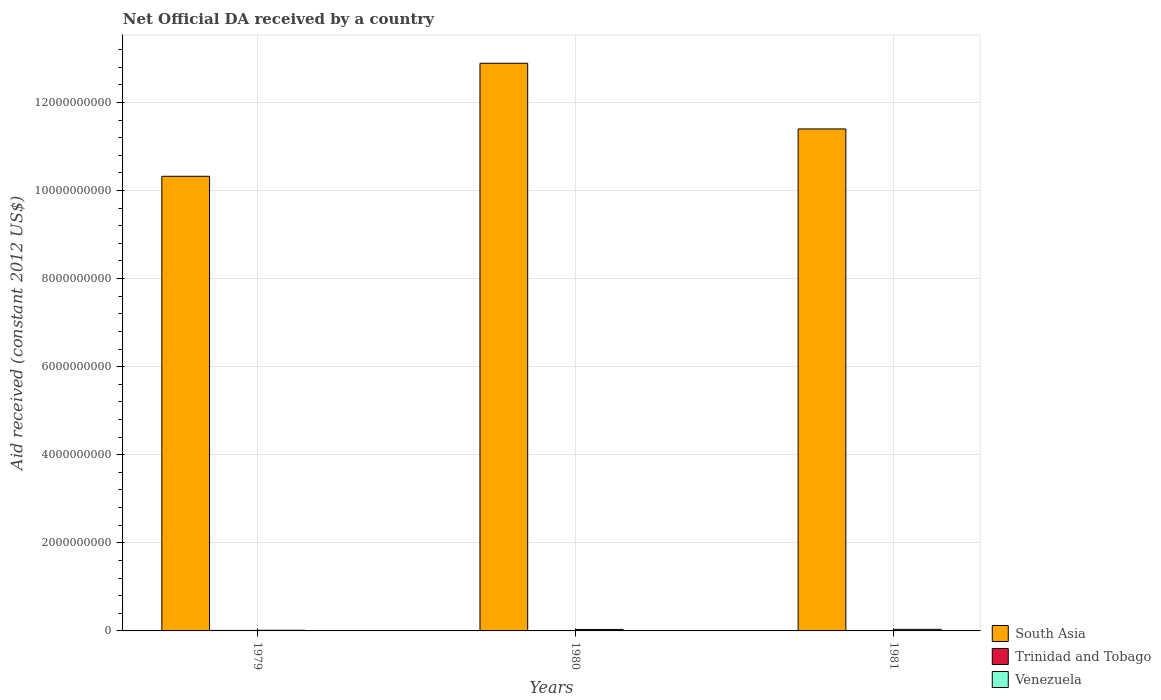Are the number of bars on each tick of the X-axis equal?
Ensure brevity in your answer.  No. How many bars are there on the 3rd tick from the left?
Ensure brevity in your answer.  2. What is the label of the 2nd group of bars from the left?
Make the answer very short. 1980. In how many cases, is the number of bars for a given year not equal to the number of legend labels?
Keep it short and to the point. 1. What is the net official development assistance aid received in Venezuela in 1979?
Keep it short and to the point. 1.50e+07. Across all years, what is the maximum net official development assistance aid received in South Asia?
Provide a succinct answer. 1.29e+1. Across all years, what is the minimum net official development assistance aid received in Venezuela?
Your response must be concise. 1.50e+07. What is the total net official development assistance aid received in Trinidad and Tobago in the graph?
Give a very brief answer. 2.02e+07. What is the difference between the net official development assistance aid received in Trinidad and Tobago in 1979 and that in 1980?
Keep it short and to the point. 1.99e+06. What is the difference between the net official development assistance aid received in South Asia in 1979 and the net official development assistance aid received in Venezuela in 1980?
Provide a short and direct response. 1.03e+1. What is the average net official development assistance aid received in Venezuela per year?
Provide a succinct answer. 2.82e+07. In the year 1980, what is the difference between the net official development assistance aid received in Trinidad and Tobago and net official development assistance aid received in South Asia?
Make the answer very short. -1.29e+1. What is the ratio of the net official development assistance aid received in Venezuela in 1979 to that in 1981?
Your answer should be very brief. 0.42. Is the net official development assistance aid received in South Asia in 1979 less than that in 1980?
Keep it short and to the point. Yes. What is the difference between the highest and the second highest net official development assistance aid received in Venezuela?
Offer a terse response. 2.73e+06. What is the difference between the highest and the lowest net official development assistance aid received in Trinidad and Tobago?
Your answer should be compact. 1.11e+07. In how many years, is the net official development assistance aid received in South Asia greater than the average net official development assistance aid received in South Asia taken over all years?
Provide a succinct answer. 1. Is it the case that in every year, the sum of the net official development assistance aid received in Trinidad and Tobago and net official development assistance aid received in Venezuela is greater than the net official development assistance aid received in South Asia?
Make the answer very short. No. How many bars are there?
Keep it short and to the point. 8. Are all the bars in the graph horizontal?
Ensure brevity in your answer.  No. How many years are there in the graph?
Your response must be concise. 3. What is the difference between two consecutive major ticks on the Y-axis?
Ensure brevity in your answer.  2.00e+09. Does the graph contain any zero values?
Offer a very short reply. Yes. Does the graph contain grids?
Offer a terse response. Yes. How many legend labels are there?
Keep it short and to the point. 3. How are the legend labels stacked?
Provide a short and direct response. Vertical. What is the title of the graph?
Ensure brevity in your answer.  Net Official DA received by a country. What is the label or title of the X-axis?
Offer a very short reply. Years. What is the label or title of the Y-axis?
Your response must be concise. Aid received (constant 2012 US$). What is the Aid received (constant 2012 US$) of South Asia in 1979?
Offer a very short reply. 1.03e+1. What is the Aid received (constant 2012 US$) of Trinidad and Tobago in 1979?
Your answer should be compact. 1.11e+07. What is the Aid received (constant 2012 US$) in Venezuela in 1979?
Keep it short and to the point. 1.50e+07. What is the Aid received (constant 2012 US$) of South Asia in 1980?
Make the answer very short. 1.29e+1. What is the Aid received (constant 2012 US$) in Trinidad and Tobago in 1980?
Give a very brief answer. 9.10e+06. What is the Aid received (constant 2012 US$) of Venezuela in 1980?
Ensure brevity in your answer.  3.34e+07. What is the Aid received (constant 2012 US$) in South Asia in 1981?
Keep it short and to the point. 1.14e+1. What is the Aid received (constant 2012 US$) of Venezuela in 1981?
Offer a very short reply. 3.61e+07. Across all years, what is the maximum Aid received (constant 2012 US$) of South Asia?
Provide a succinct answer. 1.29e+1. Across all years, what is the maximum Aid received (constant 2012 US$) of Trinidad and Tobago?
Provide a short and direct response. 1.11e+07. Across all years, what is the maximum Aid received (constant 2012 US$) in Venezuela?
Make the answer very short. 3.61e+07. Across all years, what is the minimum Aid received (constant 2012 US$) of South Asia?
Give a very brief answer. 1.03e+1. Across all years, what is the minimum Aid received (constant 2012 US$) of Venezuela?
Offer a very short reply. 1.50e+07. What is the total Aid received (constant 2012 US$) in South Asia in the graph?
Keep it short and to the point. 3.46e+1. What is the total Aid received (constant 2012 US$) in Trinidad and Tobago in the graph?
Offer a terse response. 2.02e+07. What is the total Aid received (constant 2012 US$) of Venezuela in the graph?
Your response must be concise. 8.45e+07. What is the difference between the Aid received (constant 2012 US$) of South Asia in 1979 and that in 1980?
Give a very brief answer. -2.57e+09. What is the difference between the Aid received (constant 2012 US$) in Trinidad and Tobago in 1979 and that in 1980?
Offer a very short reply. 1.99e+06. What is the difference between the Aid received (constant 2012 US$) in Venezuela in 1979 and that in 1980?
Provide a succinct answer. -1.84e+07. What is the difference between the Aid received (constant 2012 US$) of South Asia in 1979 and that in 1981?
Offer a very short reply. -1.08e+09. What is the difference between the Aid received (constant 2012 US$) in Venezuela in 1979 and that in 1981?
Ensure brevity in your answer.  -2.11e+07. What is the difference between the Aid received (constant 2012 US$) of South Asia in 1980 and that in 1981?
Give a very brief answer. 1.49e+09. What is the difference between the Aid received (constant 2012 US$) of Venezuela in 1980 and that in 1981?
Offer a very short reply. -2.73e+06. What is the difference between the Aid received (constant 2012 US$) of South Asia in 1979 and the Aid received (constant 2012 US$) of Trinidad and Tobago in 1980?
Ensure brevity in your answer.  1.03e+1. What is the difference between the Aid received (constant 2012 US$) of South Asia in 1979 and the Aid received (constant 2012 US$) of Venezuela in 1980?
Your answer should be compact. 1.03e+1. What is the difference between the Aid received (constant 2012 US$) of Trinidad and Tobago in 1979 and the Aid received (constant 2012 US$) of Venezuela in 1980?
Keep it short and to the point. -2.23e+07. What is the difference between the Aid received (constant 2012 US$) in South Asia in 1979 and the Aid received (constant 2012 US$) in Venezuela in 1981?
Your answer should be compact. 1.03e+1. What is the difference between the Aid received (constant 2012 US$) in Trinidad and Tobago in 1979 and the Aid received (constant 2012 US$) in Venezuela in 1981?
Your answer should be compact. -2.50e+07. What is the difference between the Aid received (constant 2012 US$) of South Asia in 1980 and the Aid received (constant 2012 US$) of Venezuela in 1981?
Your answer should be very brief. 1.29e+1. What is the difference between the Aid received (constant 2012 US$) of Trinidad and Tobago in 1980 and the Aid received (constant 2012 US$) of Venezuela in 1981?
Your answer should be very brief. -2.70e+07. What is the average Aid received (constant 2012 US$) of South Asia per year?
Make the answer very short. 1.15e+1. What is the average Aid received (constant 2012 US$) of Trinidad and Tobago per year?
Ensure brevity in your answer.  6.73e+06. What is the average Aid received (constant 2012 US$) in Venezuela per year?
Keep it short and to the point. 2.82e+07. In the year 1979, what is the difference between the Aid received (constant 2012 US$) in South Asia and Aid received (constant 2012 US$) in Trinidad and Tobago?
Your answer should be very brief. 1.03e+1. In the year 1979, what is the difference between the Aid received (constant 2012 US$) in South Asia and Aid received (constant 2012 US$) in Venezuela?
Ensure brevity in your answer.  1.03e+1. In the year 1979, what is the difference between the Aid received (constant 2012 US$) of Trinidad and Tobago and Aid received (constant 2012 US$) of Venezuela?
Your answer should be very brief. -3.91e+06. In the year 1980, what is the difference between the Aid received (constant 2012 US$) in South Asia and Aid received (constant 2012 US$) in Trinidad and Tobago?
Your answer should be compact. 1.29e+1. In the year 1980, what is the difference between the Aid received (constant 2012 US$) of South Asia and Aid received (constant 2012 US$) of Venezuela?
Ensure brevity in your answer.  1.29e+1. In the year 1980, what is the difference between the Aid received (constant 2012 US$) in Trinidad and Tobago and Aid received (constant 2012 US$) in Venezuela?
Provide a short and direct response. -2.43e+07. In the year 1981, what is the difference between the Aid received (constant 2012 US$) in South Asia and Aid received (constant 2012 US$) in Venezuela?
Provide a short and direct response. 1.14e+1. What is the ratio of the Aid received (constant 2012 US$) of South Asia in 1979 to that in 1980?
Your answer should be very brief. 0.8. What is the ratio of the Aid received (constant 2012 US$) in Trinidad and Tobago in 1979 to that in 1980?
Offer a very short reply. 1.22. What is the ratio of the Aid received (constant 2012 US$) of Venezuela in 1979 to that in 1980?
Your answer should be very brief. 0.45. What is the ratio of the Aid received (constant 2012 US$) in South Asia in 1979 to that in 1981?
Give a very brief answer. 0.91. What is the ratio of the Aid received (constant 2012 US$) of Venezuela in 1979 to that in 1981?
Give a very brief answer. 0.42. What is the ratio of the Aid received (constant 2012 US$) in South Asia in 1980 to that in 1981?
Provide a short and direct response. 1.13. What is the ratio of the Aid received (constant 2012 US$) of Venezuela in 1980 to that in 1981?
Give a very brief answer. 0.92. What is the difference between the highest and the second highest Aid received (constant 2012 US$) in South Asia?
Ensure brevity in your answer.  1.49e+09. What is the difference between the highest and the second highest Aid received (constant 2012 US$) in Venezuela?
Offer a terse response. 2.73e+06. What is the difference between the highest and the lowest Aid received (constant 2012 US$) in South Asia?
Your response must be concise. 2.57e+09. What is the difference between the highest and the lowest Aid received (constant 2012 US$) of Trinidad and Tobago?
Keep it short and to the point. 1.11e+07. What is the difference between the highest and the lowest Aid received (constant 2012 US$) in Venezuela?
Ensure brevity in your answer.  2.11e+07. 